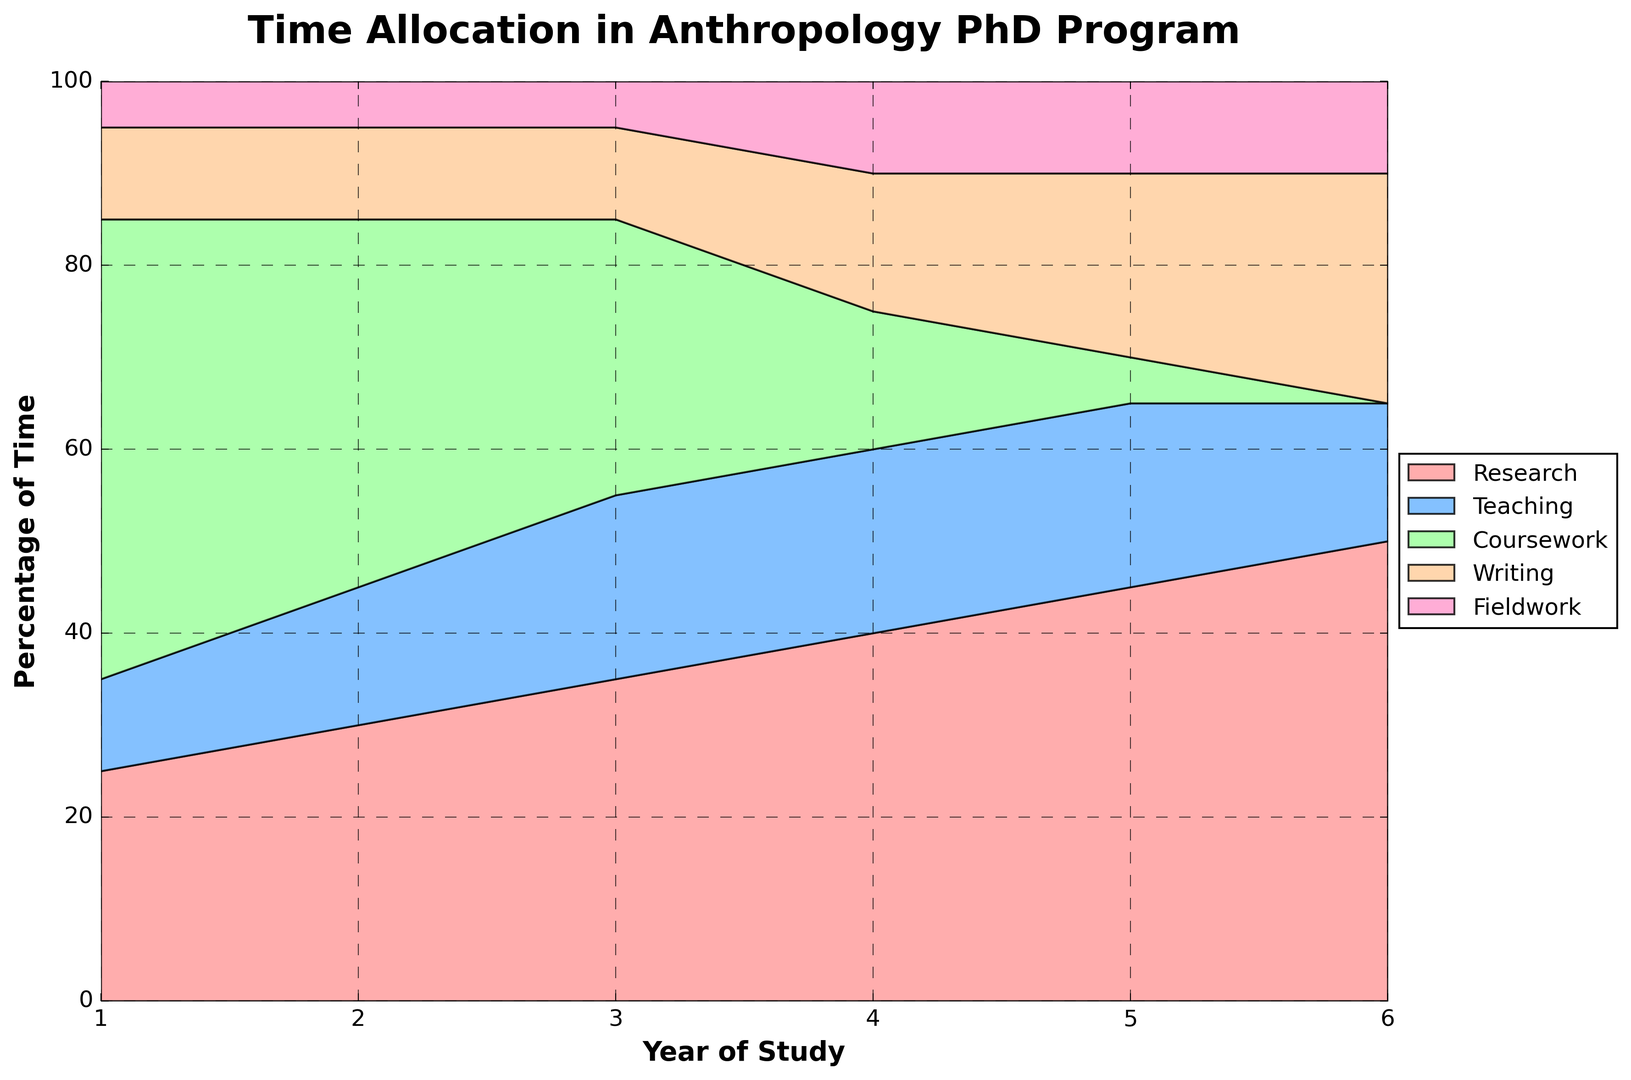How does the time spent on research change from Year 1 to Year 6? In Year 1, time spent on research is 25%, and it increases to 50% by Year 6.
Answer: It increases by 25% Which activity takes the least amount of time overall? For most years, Fieldwork has the lowest percentage. It remains consistently at 5-10% each year.
Answer: Fieldwork Is there any year where coursework takes more time than any other activities combined? In Year 1, Coursework is 50%, while combined percentages of other activities are: 25 (Research) + 10 (Teaching) + 10 (Writing) + 5 (Fieldwork) = 50%. Thus, Coursework doesn't exceed all other activities.
Answer: No By how much does time spent on teaching change from Year 2 to Year 6? In Year 2, Teaching is 15%, and in Year 6, it is 15% as well; there is no change.
Answer: 0% What is the difference in percentage of time spent on writing between Year 4 and Year 6? In Year 4, Writing takes 15% and in Year 6, it takes 25%. The difference is 25% - 15% = 10%.
Answer: 10% Which years have the highest percentage of time spent on fieldwork, and what is that percentage? Both Year 4 and Year 5 have the highest percentage of time spent on Fieldwork, which is 10%.
Answer: Years 4 and 5, 10% What is the total percentage of time spent on Teaching and Fieldwork in Year 3? Percentage for Teaching is 20% and Fieldwork is 5%. Total is 20% + 5% = 25%.
Answer: 25% Which two activities see the biggest increase in time from Year 1 to Year 6? Research increases from 25% to 50% (25% increase) and Writing increases from 10% to 25% (15% increase). These are the largest increases.
Answer: Research and Writing In which year does Research surpass 40% of the time, and by how much does it surpass? Research surpasses 40% in Year 5 where it is at 45%. It surpasses by 45% - 40% = 5%.
Answer: Year 5, 5% What visual cues indicate that writing becomes more important in later years of the program? The section for Writing in the area chart grows significantly larger, especially after Year 4. It changes from a thin band to a more prominent section, visually indicating increased importance.
Answer: Increasing size of the Writing section 